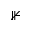<formula> <loc_0><loc_0><loc_500><loc_500>\nVdash</formula> 